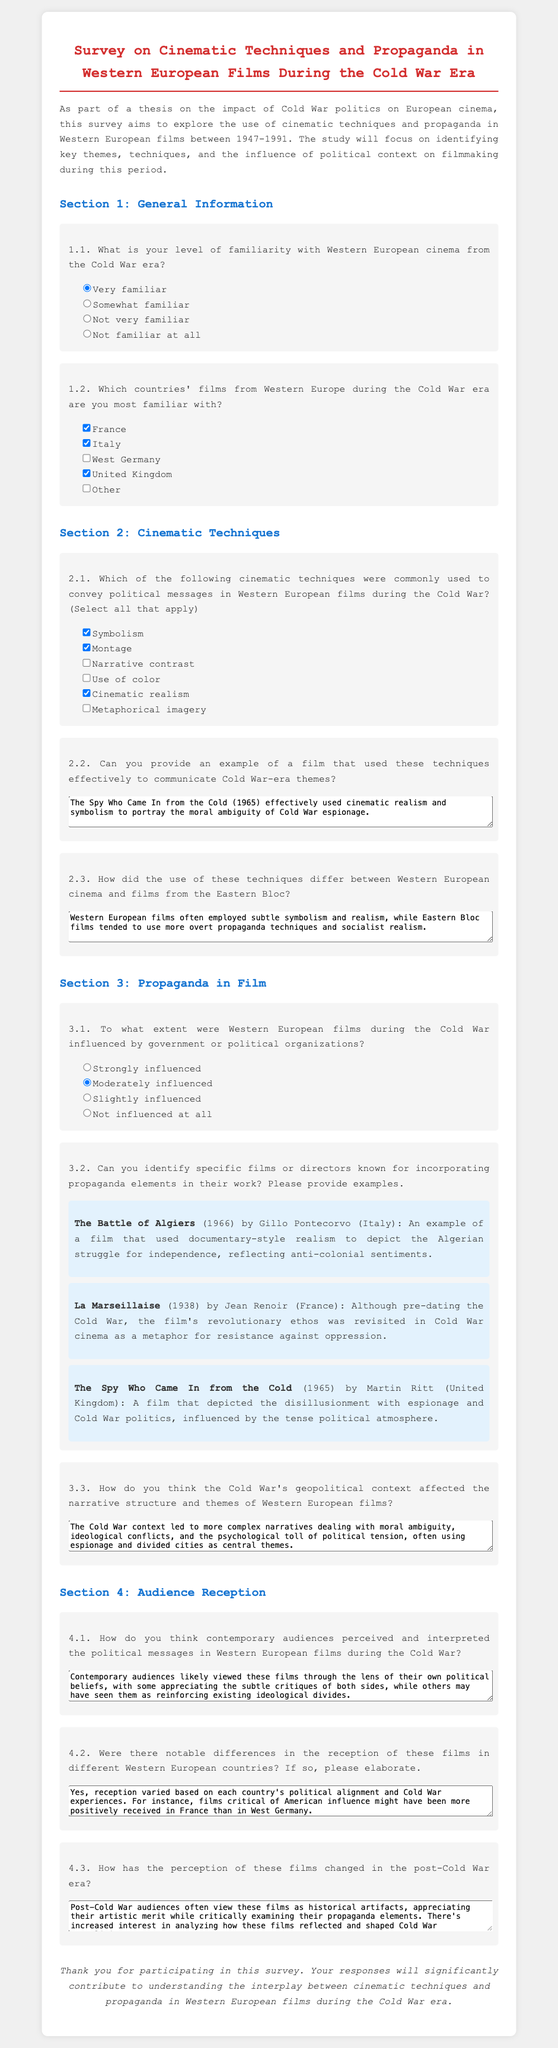What is the title of the survey? The title of the survey is prominently displayed at the top of the document.
Answer: Survey on Cinematic Techniques and Propaganda in Western European Films During the Cold War Era What is the timeframe discussed in the survey? The survey specifies the years during which Western European cinema is analyzed.
Answer: 1947-1991 Which film is mentioned as using realism and symbolism? An example film is provided in Section 2.2 to illustrate effective use of cinematic techniques.
Answer: The Spy Who Came In from the Cold What is the selection in question 1.1 for familiarity? The option selected reflects the respondent's self-reported level of familiarity with Western European cinema.
Answer: Very familiar Which countries are included in question 1.2 that the respondent is familiar with? The selected countries are listed in checkbox options, showcasing familiarity.
Answer: France, Italy, United Kingdom How does question 3.1 gauge influence? This question assesses the degree of political influence on Western European films during the Cold War.
Answer: Moderately influenced What type of examples are requested in question 3.2? This question asks for identifiable films or directors that incorporated propaganda elements in their work.
Answer: Films or directors known for propaganda elements What is suggested about film reception in question 4.2? This question explores the variations in how films were received across different Western European countries.
Answer: Notable differences What is the concluding remark of the survey? The last statement expresses gratitude for participation and the importance of responses.
Answer: Thank you for participating in this survey 